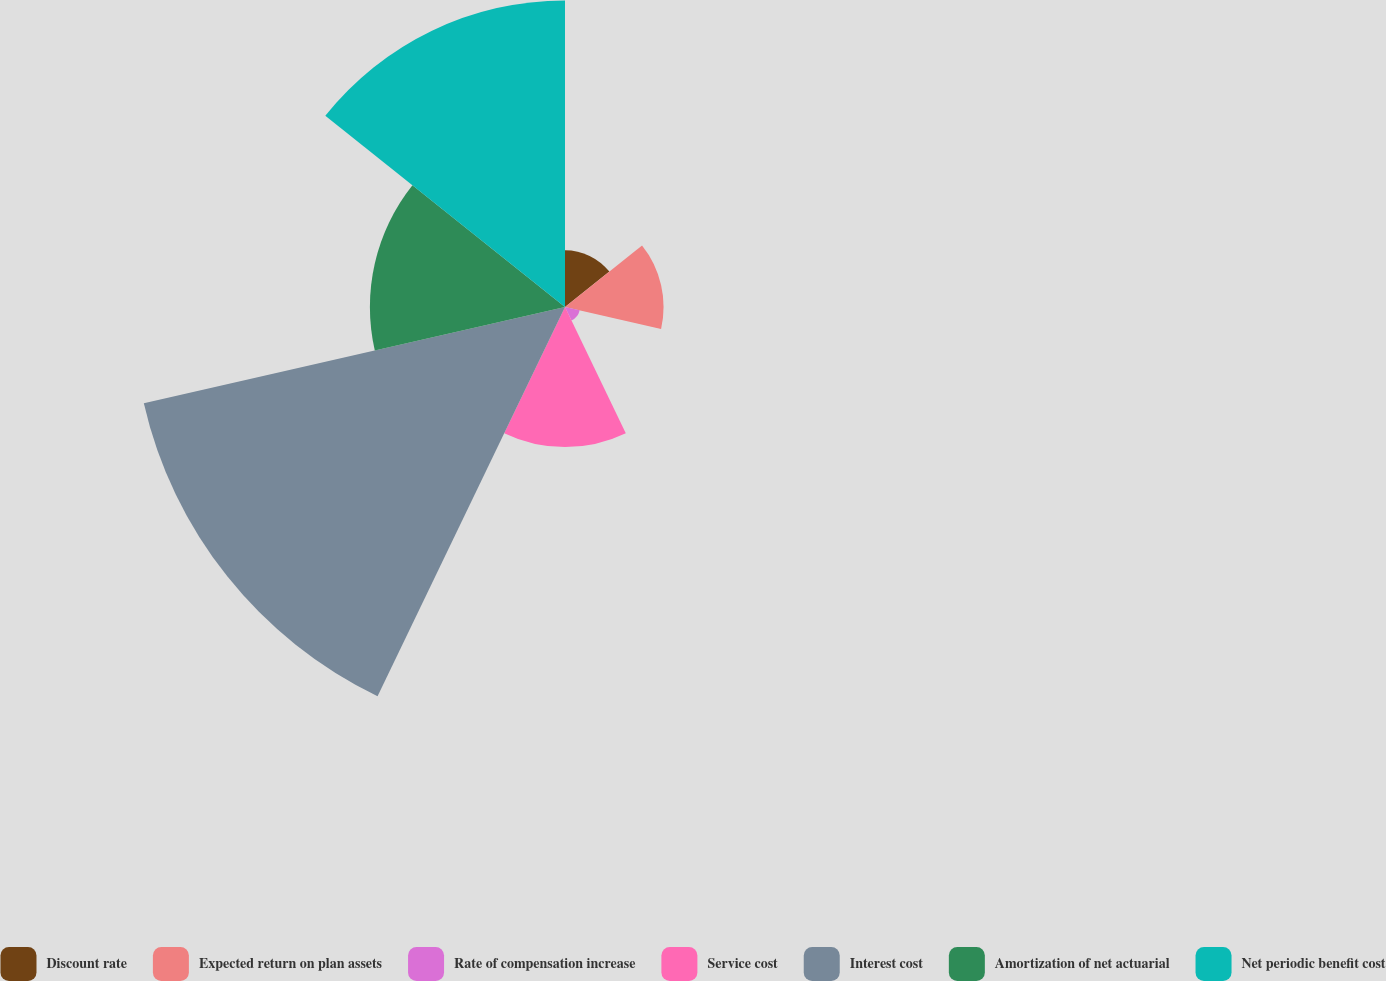Convert chart. <chart><loc_0><loc_0><loc_500><loc_500><pie_chart><fcel>Discount rate<fcel>Expected return on plan assets<fcel>Rate of compensation increase<fcel>Service cost<fcel>Interest cost<fcel>Amortization of net actuarial<fcel>Net periodic benefit cost<nl><fcel>4.56%<fcel>7.92%<fcel>1.21%<fcel>11.26%<fcel>34.72%<fcel>15.68%<fcel>24.64%<nl></chart> 